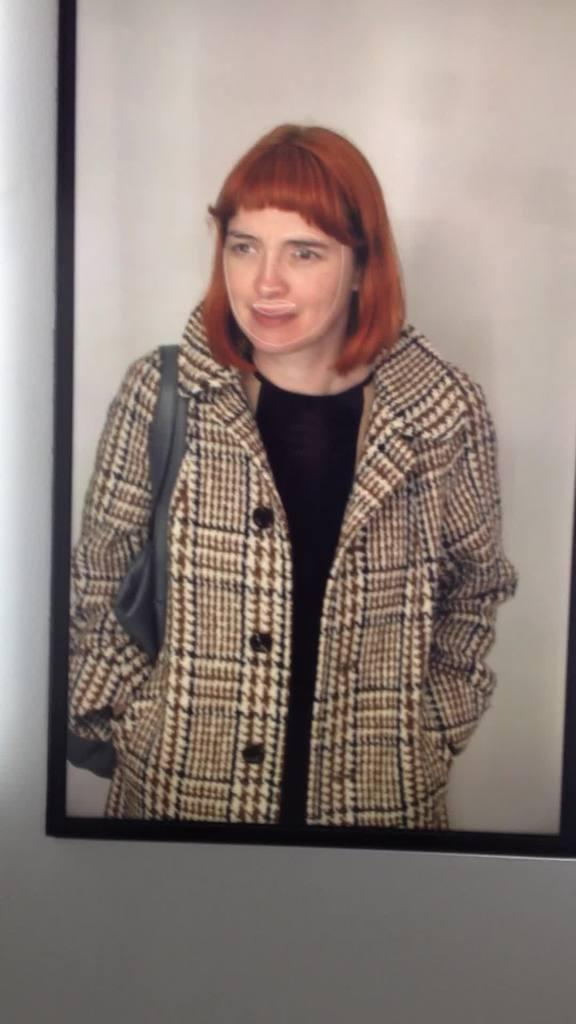What can be seen in the image? There is a person in the image. Can you describe the person's attire? The person is wearing a black and brown color dress. What is the person carrying in the image? The person is carrying a grey color bag. How is the image displayed? The image is framed. What color is the wall the frame is attached to? The frame is attached to a white wall. How many kittens are visible in the image? There are no kittens visible in the image. What does the caption say about the person in the image? There is no caption present in the image. 